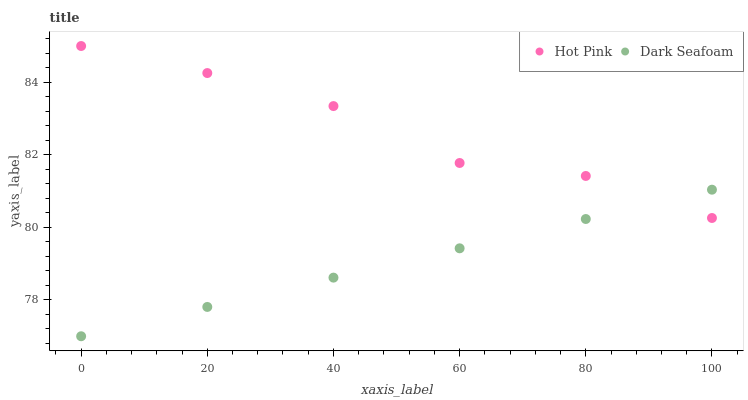Does Dark Seafoam have the minimum area under the curve?
Answer yes or no. Yes. Does Hot Pink have the maximum area under the curve?
Answer yes or no. Yes. Does Hot Pink have the minimum area under the curve?
Answer yes or no. No. Is Dark Seafoam the smoothest?
Answer yes or no. Yes. Is Hot Pink the roughest?
Answer yes or no. Yes. Is Hot Pink the smoothest?
Answer yes or no. No. Does Dark Seafoam have the lowest value?
Answer yes or no. Yes. Does Hot Pink have the lowest value?
Answer yes or no. No. Does Hot Pink have the highest value?
Answer yes or no. Yes. Does Hot Pink intersect Dark Seafoam?
Answer yes or no. Yes. Is Hot Pink less than Dark Seafoam?
Answer yes or no. No. Is Hot Pink greater than Dark Seafoam?
Answer yes or no. No. 